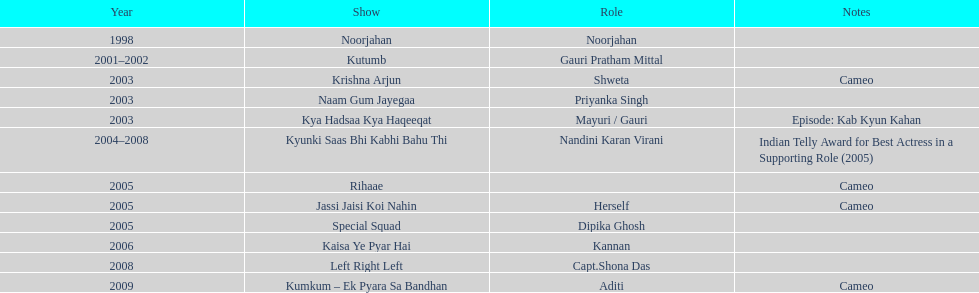In which tv show did gauri have the longest duration of participation? Kyunki Saas Bhi Kabhi Bahu Thi. 